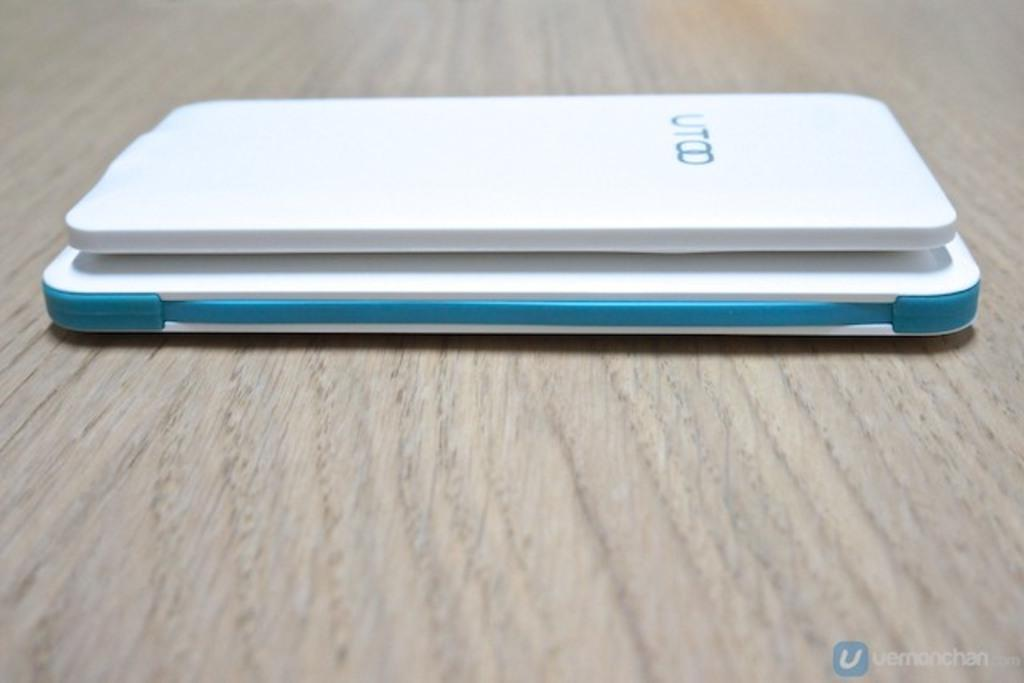<image>
Present a compact description of the photo's key features. A white device is on a table and has a UT logo on it. 